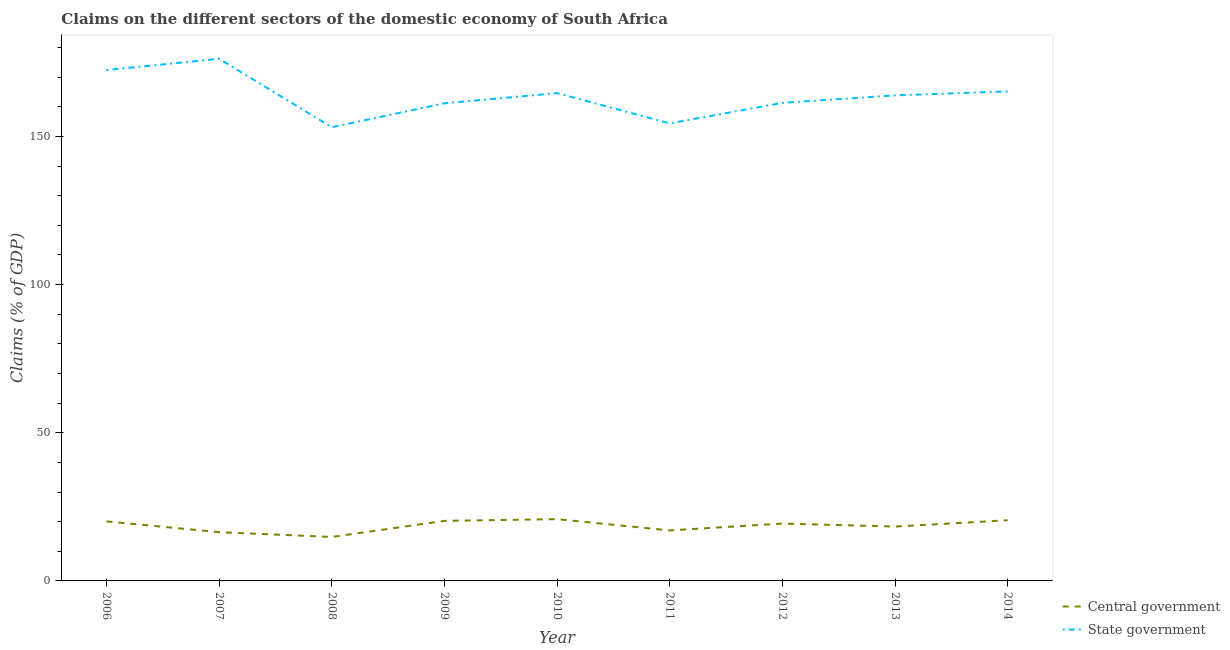How many different coloured lines are there?
Offer a terse response. 2. Does the line corresponding to claims on state government intersect with the line corresponding to claims on central government?
Give a very brief answer. No. Is the number of lines equal to the number of legend labels?
Keep it short and to the point. Yes. What is the claims on state government in 2006?
Offer a very short reply. 172.41. Across all years, what is the maximum claims on central government?
Provide a succinct answer. 20.84. Across all years, what is the minimum claims on state government?
Make the answer very short. 153.11. In which year was the claims on central government minimum?
Your answer should be very brief. 2008. What is the total claims on state government in the graph?
Your answer should be very brief. 1472.35. What is the difference between the claims on central government in 2011 and that in 2012?
Keep it short and to the point. -2.32. What is the difference between the claims on central government in 2009 and the claims on state government in 2006?
Your answer should be very brief. -152.14. What is the average claims on state government per year?
Make the answer very short. 163.59. In the year 2009, what is the difference between the claims on central government and claims on state government?
Your answer should be compact. -140.92. What is the ratio of the claims on central government in 2006 to that in 2013?
Offer a very short reply. 1.1. Is the claims on state government in 2006 less than that in 2007?
Your answer should be very brief. Yes. Is the difference between the claims on state government in 2006 and 2014 greater than the difference between the claims on central government in 2006 and 2014?
Ensure brevity in your answer.  Yes. What is the difference between the highest and the second highest claims on central government?
Your response must be concise. 0.36. What is the difference between the highest and the lowest claims on central government?
Provide a succinct answer. 6.01. In how many years, is the claims on central government greater than the average claims on central government taken over all years?
Provide a short and direct response. 5. Is the sum of the claims on state government in 2008 and 2014 greater than the maximum claims on central government across all years?
Your answer should be very brief. Yes. Does the claims on central government monotonically increase over the years?
Give a very brief answer. No. How many lines are there?
Provide a short and direct response. 2. What is the difference between two consecutive major ticks on the Y-axis?
Offer a terse response. 50. Are the values on the major ticks of Y-axis written in scientific E-notation?
Offer a very short reply. No. Where does the legend appear in the graph?
Make the answer very short. Bottom right. How many legend labels are there?
Your response must be concise. 2. How are the legend labels stacked?
Provide a succinct answer. Vertical. What is the title of the graph?
Your response must be concise. Claims on the different sectors of the domestic economy of South Africa. Does "Chemicals" appear as one of the legend labels in the graph?
Ensure brevity in your answer.  No. What is the label or title of the X-axis?
Offer a very short reply. Year. What is the label or title of the Y-axis?
Offer a very short reply. Claims (% of GDP). What is the Claims (% of GDP) in Central government in 2006?
Provide a succinct answer. 20.09. What is the Claims (% of GDP) of State government in 2006?
Provide a succinct answer. 172.41. What is the Claims (% of GDP) in Central government in 2007?
Your answer should be very brief. 16.45. What is the Claims (% of GDP) of State government in 2007?
Give a very brief answer. 176.21. What is the Claims (% of GDP) of Central government in 2008?
Offer a very short reply. 14.84. What is the Claims (% of GDP) of State government in 2008?
Offer a terse response. 153.11. What is the Claims (% of GDP) in Central government in 2009?
Your answer should be very brief. 20.27. What is the Claims (% of GDP) in State government in 2009?
Keep it short and to the point. 161.18. What is the Claims (% of GDP) in Central government in 2010?
Make the answer very short. 20.84. What is the Claims (% of GDP) of State government in 2010?
Ensure brevity in your answer.  164.63. What is the Claims (% of GDP) in Central government in 2011?
Make the answer very short. 17.04. What is the Claims (% of GDP) in State government in 2011?
Offer a very short reply. 154.42. What is the Claims (% of GDP) in Central government in 2012?
Make the answer very short. 19.36. What is the Claims (% of GDP) in State government in 2012?
Provide a succinct answer. 161.34. What is the Claims (% of GDP) in Central government in 2013?
Make the answer very short. 18.34. What is the Claims (% of GDP) in State government in 2013?
Make the answer very short. 163.86. What is the Claims (% of GDP) of Central government in 2014?
Keep it short and to the point. 20.48. What is the Claims (% of GDP) of State government in 2014?
Your response must be concise. 165.19. Across all years, what is the maximum Claims (% of GDP) of Central government?
Keep it short and to the point. 20.84. Across all years, what is the maximum Claims (% of GDP) in State government?
Give a very brief answer. 176.21. Across all years, what is the minimum Claims (% of GDP) in Central government?
Your answer should be compact. 14.84. Across all years, what is the minimum Claims (% of GDP) of State government?
Your answer should be compact. 153.11. What is the total Claims (% of GDP) in Central government in the graph?
Keep it short and to the point. 167.72. What is the total Claims (% of GDP) of State government in the graph?
Offer a very short reply. 1472.35. What is the difference between the Claims (% of GDP) in Central government in 2006 and that in 2007?
Your answer should be compact. 3.64. What is the difference between the Claims (% of GDP) of State government in 2006 and that in 2007?
Ensure brevity in your answer.  -3.8. What is the difference between the Claims (% of GDP) in Central government in 2006 and that in 2008?
Provide a succinct answer. 5.26. What is the difference between the Claims (% of GDP) of State government in 2006 and that in 2008?
Keep it short and to the point. 19.3. What is the difference between the Claims (% of GDP) of Central government in 2006 and that in 2009?
Your answer should be very brief. -0.17. What is the difference between the Claims (% of GDP) in State government in 2006 and that in 2009?
Provide a short and direct response. 11.23. What is the difference between the Claims (% of GDP) of Central government in 2006 and that in 2010?
Your answer should be compact. -0.75. What is the difference between the Claims (% of GDP) in State government in 2006 and that in 2010?
Keep it short and to the point. 7.78. What is the difference between the Claims (% of GDP) of Central government in 2006 and that in 2011?
Make the answer very short. 3.05. What is the difference between the Claims (% of GDP) of State government in 2006 and that in 2011?
Your answer should be compact. 17.99. What is the difference between the Claims (% of GDP) of Central government in 2006 and that in 2012?
Offer a very short reply. 0.73. What is the difference between the Claims (% of GDP) of State government in 2006 and that in 2012?
Your answer should be compact. 11.07. What is the difference between the Claims (% of GDP) of Central government in 2006 and that in 2013?
Provide a succinct answer. 1.75. What is the difference between the Claims (% of GDP) of State government in 2006 and that in 2013?
Ensure brevity in your answer.  8.55. What is the difference between the Claims (% of GDP) in Central government in 2006 and that in 2014?
Make the answer very short. -0.39. What is the difference between the Claims (% of GDP) in State government in 2006 and that in 2014?
Offer a terse response. 7.22. What is the difference between the Claims (% of GDP) of Central government in 2007 and that in 2008?
Make the answer very short. 1.62. What is the difference between the Claims (% of GDP) in State government in 2007 and that in 2008?
Make the answer very short. 23.1. What is the difference between the Claims (% of GDP) of Central government in 2007 and that in 2009?
Provide a short and direct response. -3.82. What is the difference between the Claims (% of GDP) in State government in 2007 and that in 2009?
Provide a short and direct response. 15.03. What is the difference between the Claims (% of GDP) in Central government in 2007 and that in 2010?
Provide a short and direct response. -4.39. What is the difference between the Claims (% of GDP) of State government in 2007 and that in 2010?
Your answer should be very brief. 11.58. What is the difference between the Claims (% of GDP) of Central government in 2007 and that in 2011?
Your response must be concise. -0.59. What is the difference between the Claims (% of GDP) in State government in 2007 and that in 2011?
Offer a terse response. 21.79. What is the difference between the Claims (% of GDP) of Central government in 2007 and that in 2012?
Your answer should be compact. -2.91. What is the difference between the Claims (% of GDP) of State government in 2007 and that in 2012?
Make the answer very short. 14.87. What is the difference between the Claims (% of GDP) of Central government in 2007 and that in 2013?
Make the answer very short. -1.89. What is the difference between the Claims (% of GDP) of State government in 2007 and that in 2013?
Your answer should be compact. 12.35. What is the difference between the Claims (% of GDP) of Central government in 2007 and that in 2014?
Ensure brevity in your answer.  -4.03. What is the difference between the Claims (% of GDP) of State government in 2007 and that in 2014?
Your answer should be very brief. 11.02. What is the difference between the Claims (% of GDP) in Central government in 2008 and that in 2009?
Your answer should be very brief. -5.43. What is the difference between the Claims (% of GDP) of State government in 2008 and that in 2009?
Your response must be concise. -8.08. What is the difference between the Claims (% of GDP) of Central government in 2008 and that in 2010?
Provide a succinct answer. -6.01. What is the difference between the Claims (% of GDP) in State government in 2008 and that in 2010?
Keep it short and to the point. -11.52. What is the difference between the Claims (% of GDP) in Central government in 2008 and that in 2011?
Make the answer very short. -2.21. What is the difference between the Claims (% of GDP) in State government in 2008 and that in 2011?
Give a very brief answer. -1.31. What is the difference between the Claims (% of GDP) of Central government in 2008 and that in 2012?
Offer a terse response. -4.53. What is the difference between the Claims (% of GDP) of State government in 2008 and that in 2012?
Give a very brief answer. -8.23. What is the difference between the Claims (% of GDP) in Central government in 2008 and that in 2013?
Ensure brevity in your answer.  -3.51. What is the difference between the Claims (% of GDP) in State government in 2008 and that in 2013?
Offer a terse response. -10.76. What is the difference between the Claims (% of GDP) in Central government in 2008 and that in 2014?
Your answer should be compact. -5.65. What is the difference between the Claims (% of GDP) in State government in 2008 and that in 2014?
Keep it short and to the point. -12.09. What is the difference between the Claims (% of GDP) in Central government in 2009 and that in 2010?
Keep it short and to the point. -0.58. What is the difference between the Claims (% of GDP) of State government in 2009 and that in 2010?
Your response must be concise. -3.45. What is the difference between the Claims (% of GDP) in Central government in 2009 and that in 2011?
Provide a short and direct response. 3.22. What is the difference between the Claims (% of GDP) of State government in 2009 and that in 2011?
Offer a terse response. 6.76. What is the difference between the Claims (% of GDP) in Central government in 2009 and that in 2012?
Ensure brevity in your answer.  0.91. What is the difference between the Claims (% of GDP) in State government in 2009 and that in 2012?
Keep it short and to the point. -0.16. What is the difference between the Claims (% of GDP) in Central government in 2009 and that in 2013?
Provide a succinct answer. 1.93. What is the difference between the Claims (% of GDP) of State government in 2009 and that in 2013?
Your answer should be very brief. -2.68. What is the difference between the Claims (% of GDP) in Central government in 2009 and that in 2014?
Offer a very short reply. -0.21. What is the difference between the Claims (% of GDP) in State government in 2009 and that in 2014?
Make the answer very short. -4.01. What is the difference between the Claims (% of GDP) in Central government in 2010 and that in 2011?
Provide a succinct answer. 3.8. What is the difference between the Claims (% of GDP) in State government in 2010 and that in 2011?
Your answer should be compact. 10.21. What is the difference between the Claims (% of GDP) in Central government in 2010 and that in 2012?
Ensure brevity in your answer.  1.48. What is the difference between the Claims (% of GDP) in State government in 2010 and that in 2012?
Give a very brief answer. 3.29. What is the difference between the Claims (% of GDP) in Central government in 2010 and that in 2013?
Offer a terse response. 2.5. What is the difference between the Claims (% of GDP) of State government in 2010 and that in 2013?
Offer a terse response. 0.77. What is the difference between the Claims (% of GDP) of Central government in 2010 and that in 2014?
Offer a terse response. 0.36. What is the difference between the Claims (% of GDP) in State government in 2010 and that in 2014?
Give a very brief answer. -0.56. What is the difference between the Claims (% of GDP) in Central government in 2011 and that in 2012?
Offer a terse response. -2.32. What is the difference between the Claims (% of GDP) of State government in 2011 and that in 2012?
Make the answer very short. -6.92. What is the difference between the Claims (% of GDP) of Central government in 2011 and that in 2013?
Make the answer very short. -1.3. What is the difference between the Claims (% of GDP) of State government in 2011 and that in 2013?
Offer a very short reply. -9.44. What is the difference between the Claims (% of GDP) of Central government in 2011 and that in 2014?
Ensure brevity in your answer.  -3.44. What is the difference between the Claims (% of GDP) in State government in 2011 and that in 2014?
Offer a terse response. -10.77. What is the difference between the Claims (% of GDP) of Central government in 2012 and that in 2013?
Keep it short and to the point. 1.02. What is the difference between the Claims (% of GDP) of State government in 2012 and that in 2013?
Your answer should be very brief. -2.52. What is the difference between the Claims (% of GDP) in Central government in 2012 and that in 2014?
Your response must be concise. -1.12. What is the difference between the Claims (% of GDP) in State government in 2012 and that in 2014?
Your response must be concise. -3.85. What is the difference between the Claims (% of GDP) of Central government in 2013 and that in 2014?
Give a very brief answer. -2.14. What is the difference between the Claims (% of GDP) of State government in 2013 and that in 2014?
Your response must be concise. -1.33. What is the difference between the Claims (% of GDP) in Central government in 2006 and the Claims (% of GDP) in State government in 2007?
Give a very brief answer. -156.12. What is the difference between the Claims (% of GDP) in Central government in 2006 and the Claims (% of GDP) in State government in 2008?
Give a very brief answer. -133.01. What is the difference between the Claims (% of GDP) in Central government in 2006 and the Claims (% of GDP) in State government in 2009?
Make the answer very short. -141.09. What is the difference between the Claims (% of GDP) in Central government in 2006 and the Claims (% of GDP) in State government in 2010?
Provide a succinct answer. -144.54. What is the difference between the Claims (% of GDP) in Central government in 2006 and the Claims (% of GDP) in State government in 2011?
Provide a succinct answer. -134.33. What is the difference between the Claims (% of GDP) in Central government in 2006 and the Claims (% of GDP) in State government in 2012?
Provide a succinct answer. -141.24. What is the difference between the Claims (% of GDP) of Central government in 2006 and the Claims (% of GDP) of State government in 2013?
Offer a very short reply. -143.77. What is the difference between the Claims (% of GDP) of Central government in 2006 and the Claims (% of GDP) of State government in 2014?
Your answer should be very brief. -145.1. What is the difference between the Claims (% of GDP) in Central government in 2007 and the Claims (% of GDP) in State government in 2008?
Offer a terse response. -136.66. What is the difference between the Claims (% of GDP) of Central government in 2007 and the Claims (% of GDP) of State government in 2009?
Your response must be concise. -144.73. What is the difference between the Claims (% of GDP) of Central government in 2007 and the Claims (% of GDP) of State government in 2010?
Give a very brief answer. -148.18. What is the difference between the Claims (% of GDP) in Central government in 2007 and the Claims (% of GDP) in State government in 2011?
Your answer should be very brief. -137.97. What is the difference between the Claims (% of GDP) of Central government in 2007 and the Claims (% of GDP) of State government in 2012?
Your answer should be very brief. -144.89. What is the difference between the Claims (% of GDP) of Central government in 2007 and the Claims (% of GDP) of State government in 2013?
Provide a short and direct response. -147.41. What is the difference between the Claims (% of GDP) in Central government in 2007 and the Claims (% of GDP) in State government in 2014?
Provide a succinct answer. -148.74. What is the difference between the Claims (% of GDP) of Central government in 2008 and the Claims (% of GDP) of State government in 2009?
Ensure brevity in your answer.  -146.35. What is the difference between the Claims (% of GDP) of Central government in 2008 and the Claims (% of GDP) of State government in 2010?
Ensure brevity in your answer.  -149.8. What is the difference between the Claims (% of GDP) in Central government in 2008 and the Claims (% of GDP) in State government in 2011?
Your answer should be very brief. -139.58. What is the difference between the Claims (% of GDP) in Central government in 2008 and the Claims (% of GDP) in State government in 2012?
Your response must be concise. -146.5. What is the difference between the Claims (% of GDP) in Central government in 2008 and the Claims (% of GDP) in State government in 2013?
Your response must be concise. -149.03. What is the difference between the Claims (% of GDP) in Central government in 2008 and the Claims (% of GDP) in State government in 2014?
Offer a very short reply. -150.36. What is the difference between the Claims (% of GDP) of Central government in 2009 and the Claims (% of GDP) of State government in 2010?
Provide a short and direct response. -144.36. What is the difference between the Claims (% of GDP) of Central government in 2009 and the Claims (% of GDP) of State government in 2011?
Your answer should be very brief. -134.15. What is the difference between the Claims (% of GDP) of Central government in 2009 and the Claims (% of GDP) of State government in 2012?
Give a very brief answer. -141.07. What is the difference between the Claims (% of GDP) of Central government in 2009 and the Claims (% of GDP) of State government in 2013?
Provide a succinct answer. -143.6. What is the difference between the Claims (% of GDP) in Central government in 2009 and the Claims (% of GDP) in State government in 2014?
Give a very brief answer. -144.93. What is the difference between the Claims (% of GDP) of Central government in 2010 and the Claims (% of GDP) of State government in 2011?
Offer a terse response. -133.57. What is the difference between the Claims (% of GDP) in Central government in 2010 and the Claims (% of GDP) in State government in 2012?
Give a very brief answer. -140.49. What is the difference between the Claims (% of GDP) of Central government in 2010 and the Claims (% of GDP) of State government in 2013?
Offer a terse response. -143.02. What is the difference between the Claims (% of GDP) in Central government in 2010 and the Claims (% of GDP) in State government in 2014?
Keep it short and to the point. -144.35. What is the difference between the Claims (% of GDP) of Central government in 2011 and the Claims (% of GDP) of State government in 2012?
Keep it short and to the point. -144.29. What is the difference between the Claims (% of GDP) in Central government in 2011 and the Claims (% of GDP) in State government in 2013?
Your response must be concise. -146.82. What is the difference between the Claims (% of GDP) of Central government in 2011 and the Claims (% of GDP) of State government in 2014?
Provide a short and direct response. -148.15. What is the difference between the Claims (% of GDP) in Central government in 2012 and the Claims (% of GDP) in State government in 2013?
Keep it short and to the point. -144.5. What is the difference between the Claims (% of GDP) in Central government in 2012 and the Claims (% of GDP) in State government in 2014?
Ensure brevity in your answer.  -145.83. What is the difference between the Claims (% of GDP) of Central government in 2013 and the Claims (% of GDP) of State government in 2014?
Offer a very short reply. -146.85. What is the average Claims (% of GDP) of Central government per year?
Provide a succinct answer. 18.64. What is the average Claims (% of GDP) of State government per year?
Provide a short and direct response. 163.59. In the year 2006, what is the difference between the Claims (% of GDP) in Central government and Claims (% of GDP) in State government?
Make the answer very short. -152.32. In the year 2007, what is the difference between the Claims (% of GDP) of Central government and Claims (% of GDP) of State government?
Ensure brevity in your answer.  -159.76. In the year 2008, what is the difference between the Claims (% of GDP) of Central government and Claims (% of GDP) of State government?
Offer a very short reply. -138.27. In the year 2009, what is the difference between the Claims (% of GDP) in Central government and Claims (% of GDP) in State government?
Your answer should be compact. -140.92. In the year 2010, what is the difference between the Claims (% of GDP) in Central government and Claims (% of GDP) in State government?
Your response must be concise. -143.79. In the year 2011, what is the difference between the Claims (% of GDP) of Central government and Claims (% of GDP) of State government?
Make the answer very short. -137.37. In the year 2012, what is the difference between the Claims (% of GDP) of Central government and Claims (% of GDP) of State government?
Give a very brief answer. -141.98. In the year 2013, what is the difference between the Claims (% of GDP) of Central government and Claims (% of GDP) of State government?
Make the answer very short. -145.52. In the year 2014, what is the difference between the Claims (% of GDP) of Central government and Claims (% of GDP) of State government?
Ensure brevity in your answer.  -144.71. What is the ratio of the Claims (% of GDP) in Central government in 2006 to that in 2007?
Give a very brief answer. 1.22. What is the ratio of the Claims (% of GDP) in State government in 2006 to that in 2007?
Offer a very short reply. 0.98. What is the ratio of the Claims (% of GDP) of Central government in 2006 to that in 2008?
Make the answer very short. 1.35. What is the ratio of the Claims (% of GDP) of State government in 2006 to that in 2008?
Give a very brief answer. 1.13. What is the ratio of the Claims (% of GDP) of Central government in 2006 to that in 2009?
Offer a very short reply. 0.99. What is the ratio of the Claims (% of GDP) of State government in 2006 to that in 2009?
Offer a very short reply. 1.07. What is the ratio of the Claims (% of GDP) of Central government in 2006 to that in 2010?
Your response must be concise. 0.96. What is the ratio of the Claims (% of GDP) in State government in 2006 to that in 2010?
Give a very brief answer. 1.05. What is the ratio of the Claims (% of GDP) of Central government in 2006 to that in 2011?
Your answer should be very brief. 1.18. What is the ratio of the Claims (% of GDP) in State government in 2006 to that in 2011?
Provide a short and direct response. 1.12. What is the ratio of the Claims (% of GDP) in Central government in 2006 to that in 2012?
Offer a very short reply. 1.04. What is the ratio of the Claims (% of GDP) in State government in 2006 to that in 2012?
Your answer should be compact. 1.07. What is the ratio of the Claims (% of GDP) in Central government in 2006 to that in 2013?
Offer a very short reply. 1.1. What is the ratio of the Claims (% of GDP) of State government in 2006 to that in 2013?
Keep it short and to the point. 1.05. What is the ratio of the Claims (% of GDP) of Central government in 2006 to that in 2014?
Keep it short and to the point. 0.98. What is the ratio of the Claims (% of GDP) in State government in 2006 to that in 2014?
Provide a succinct answer. 1.04. What is the ratio of the Claims (% of GDP) in Central government in 2007 to that in 2008?
Your answer should be compact. 1.11. What is the ratio of the Claims (% of GDP) of State government in 2007 to that in 2008?
Keep it short and to the point. 1.15. What is the ratio of the Claims (% of GDP) of Central government in 2007 to that in 2009?
Give a very brief answer. 0.81. What is the ratio of the Claims (% of GDP) of State government in 2007 to that in 2009?
Provide a succinct answer. 1.09. What is the ratio of the Claims (% of GDP) of Central government in 2007 to that in 2010?
Make the answer very short. 0.79. What is the ratio of the Claims (% of GDP) of State government in 2007 to that in 2010?
Offer a very short reply. 1.07. What is the ratio of the Claims (% of GDP) of Central government in 2007 to that in 2011?
Provide a short and direct response. 0.97. What is the ratio of the Claims (% of GDP) in State government in 2007 to that in 2011?
Provide a short and direct response. 1.14. What is the ratio of the Claims (% of GDP) of Central government in 2007 to that in 2012?
Your response must be concise. 0.85. What is the ratio of the Claims (% of GDP) in State government in 2007 to that in 2012?
Your answer should be compact. 1.09. What is the ratio of the Claims (% of GDP) of Central government in 2007 to that in 2013?
Your response must be concise. 0.9. What is the ratio of the Claims (% of GDP) of State government in 2007 to that in 2013?
Offer a terse response. 1.08. What is the ratio of the Claims (% of GDP) in Central government in 2007 to that in 2014?
Provide a succinct answer. 0.8. What is the ratio of the Claims (% of GDP) in State government in 2007 to that in 2014?
Keep it short and to the point. 1.07. What is the ratio of the Claims (% of GDP) of Central government in 2008 to that in 2009?
Your answer should be compact. 0.73. What is the ratio of the Claims (% of GDP) of State government in 2008 to that in 2009?
Give a very brief answer. 0.95. What is the ratio of the Claims (% of GDP) of Central government in 2008 to that in 2010?
Ensure brevity in your answer.  0.71. What is the ratio of the Claims (% of GDP) in State government in 2008 to that in 2010?
Your answer should be compact. 0.93. What is the ratio of the Claims (% of GDP) of Central government in 2008 to that in 2011?
Your answer should be very brief. 0.87. What is the ratio of the Claims (% of GDP) in State government in 2008 to that in 2011?
Offer a terse response. 0.99. What is the ratio of the Claims (% of GDP) in Central government in 2008 to that in 2012?
Keep it short and to the point. 0.77. What is the ratio of the Claims (% of GDP) in State government in 2008 to that in 2012?
Offer a very short reply. 0.95. What is the ratio of the Claims (% of GDP) in Central government in 2008 to that in 2013?
Your response must be concise. 0.81. What is the ratio of the Claims (% of GDP) of State government in 2008 to that in 2013?
Provide a short and direct response. 0.93. What is the ratio of the Claims (% of GDP) of Central government in 2008 to that in 2014?
Offer a terse response. 0.72. What is the ratio of the Claims (% of GDP) in State government in 2008 to that in 2014?
Offer a terse response. 0.93. What is the ratio of the Claims (% of GDP) of Central government in 2009 to that in 2010?
Ensure brevity in your answer.  0.97. What is the ratio of the Claims (% of GDP) in State government in 2009 to that in 2010?
Ensure brevity in your answer.  0.98. What is the ratio of the Claims (% of GDP) of Central government in 2009 to that in 2011?
Keep it short and to the point. 1.19. What is the ratio of the Claims (% of GDP) of State government in 2009 to that in 2011?
Ensure brevity in your answer.  1.04. What is the ratio of the Claims (% of GDP) in Central government in 2009 to that in 2012?
Offer a terse response. 1.05. What is the ratio of the Claims (% of GDP) in State government in 2009 to that in 2012?
Provide a short and direct response. 1. What is the ratio of the Claims (% of GDP) of Central government in 2009 to that in 2013?
Provide a short and direct response. 1.1. What is the ratio of the Claims (% of GDP) of State government in 2009 to that in 2013?
Offer a terse response. 0.98. What is the ratio of the Claims (% of GDP) in State government in 2009 to that in 2014?
Ensure brevity in your answer.  0.98. What is the ratio of the Claims (% of GDP) in Central government in 2010 to that in 2011?
Ensure brevity in your answer.  1.22. What is the ratio of the Claims (% of GDP) of State government in 2010 to that in 2011?
Ensure brevity in your answer.  1.07. What is the ratio of the Claims (% of GDP) in Central government in 2010 to that in 2012?
Give a very brief answer. 1.08. What is the ratio of the Claims (% of GDP) in State government in 2010 to that in 2012?
Offer a very short reply. 1.02. What is the ratio of the Claims (% of GDP) in Central government in 2010 to that in 2013?
Your answer should be compact. 1.14. What is the ratio of the Claims (% of GDP) in Central government in 2010 to that in 2014?
Offer a very short reply. 1.02. What is the ratio of the Claims (% of GDP) in State government in 2010 to that in 2014?
Provide a short and direct response. 1. What is the ratio of the Claims (% of GDP) in Central government in 2011 to that in 2012?
Your answer should be very brief. 0.88. What is the ratio of the Claims (% of GDP) of State government in 2011 to that in 2012?
Offer a terse response. 0.96. What is the ratio of the Claims (% of GDP) in Central government in 2011 to that in 2013?
Your answer should be very brief. 0.93. What is the ratio of the Claims (% of GDP) of State government in 2011 to that in 2013?
Offer a terse response. 0.94. What is the ratio of the Claims (% of GDP) of Central government in 2011 to that in 2014?
Your answer should be compact. 0.83. What is the ratio of the Claims (% of GDP) in State government in 2011 to that in 2014?
Provide a short and direct response. 0.93. What is the ratio of the Claims (% of GDP) of Central government in 2012 to that in 2013?
Give a very brief answer. 1.06. What is the ratio of the Claims (% of GDP) of State government in 2012 to that in 2013?
Your response must be concise. 0.98. What is the ratio of the Claims (% of GDP) of Central government in 2012 to that in 2014?
Your answer should be compact. 0.95. What is the ratio of the Claims (% of GDP) in State government in 2012 to that in 2014?
Your answer should be compact. 0.98. What is the ratio of the Claims (% of GDP) of Central government in 2013 to that in 2014?
Make the answer very short. 0.9. What is the difference between the highest and the second highest Claims (% of GDP) of Central government?
Offer a terse response. 0.36. What is the difference between the highest and the second highest Claims (% of GDP) of State government?
Keep it short and to the point. 3.8. What is the difference between the highest and the lowest Claims (% of GDP) of Central government?
Make the answer very short. 6.01. What is the difference between the highest and the lowest Claims (% of GDP) in State government?
Give a very brief answer. 23.1. 